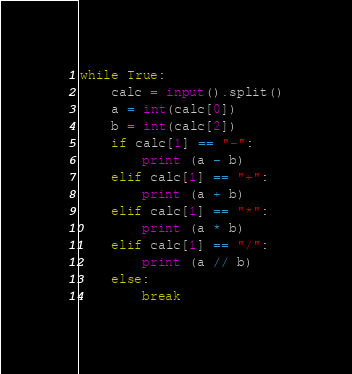<code> <loc_0><loc_0><loc_500><loc_500><_Python_>while True:
    calc = input().split()
    a = int(calc[0])
    b = int(calc[2])
    if calc[1] == "-":
        print (a - b)
    elif calc[1] == "+":
        print (a + b)
    elif calc[1] == "*":
        print (a * b)
    elif calc[1] == "/":
        print (a // b)
    else:
        break

</code> 